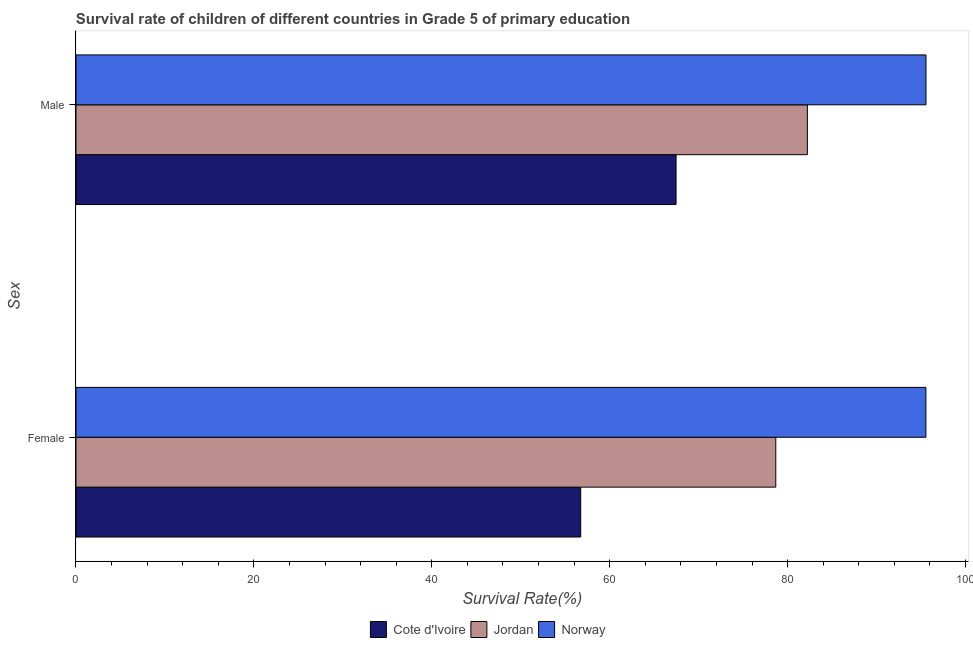How many different coloured bars are there?
Provide a short and direct response. 3. Are the number of bars per tick equal to the number of legend labels?
Provide a short and direct response. Yes. Are the number of bars on each tick of the Y-axis equal?
Your response must be concise. Yes. What is the label of the 1st group of bars from the top?
Offer a terse response. Male. What is the survival rate of male students in primary education in Jordan?
Offer a very short reply. 82.22. Across all countries, what is the maximum survival rate of male students in primary education?
Offer a terse response. 95.55. Across all countries, what is the minimum survival rate of male students in primary education?
Your answer should be compact. 67.46. In which country was the survival rate of male students in primary education minimum?
Your answer should be very brief. Cote d'Ivoire. What is the total survival rate of male students in primary education in the graph?
Offer a very short reply. 245.23. What is the difference between the survival rate of female students in primary education in Norway and that in Cote d'Ivoire?
Offer a very short reply. 38.8. What is the difference between the survival rate of female students in primary education in Norway and the survival rate of male students in primary education in Cote d'Ivoire?
Make the answer very short. 28.09. What is the average survival rate of female students in primary education per country?
Your response must be concise. 76.98. What is the difference between the survival rate of female students in primary education and survival rate of male students in primary education in Norway?
Offer a terse response. -0.01. In how many countries, is the survival rate of male students in primary education greater than 80 %?
Make the answer very short. 2. What is the ratio of the survival rate of male students in primary education in Cote d'Ivoire to that in Norway?
Ensure brevity in your answer.  0.71. Is the survival rate of male students in primary education in Cote d'Ivoire less than that in Norway?
Provide a short and direct response. Yes. In how many countries, is the survival rate of female students in primary education greater than the average survival rate of female students in primary education taken over all countries?
Provide a succinct answer. 2. What does the 2nd bar from the top in Male represents?
Offer a terse response. Jordan. What does the 3rd bar from the bottom in Female represents?
Provide a succinct answer. Norway. Are all the bars in the graph horizontal?
Give a very brief answer. Yes. Does the graph contain any zero values?
Your response must be concise. No. Does the graph contain grids?
Make the answer very short. No. How are the legend labels stacked?
Offer a very short reply. Horizontal. What is the title of the graph?
Your answer should be very brief. Survival rate of children of different countries in Grade 5 of primary education. Does "Finland" appear as one of the legend labels in the graph?
Offer a terse response. No. What is the label or title of the X-axis?
Provide a short and direct response. Survival Rate(%). What is the label or title of the Y-axis?
Make the answer very short. Sex. What is the Survival Rate(%) of Cote d'Ivoire in Female?
Make the answer very short. 56.74. What is the Survival Rate(%) of Jordan in Female?
Your answer should be compact. 78.67. What is the Survival Rate(%) in Norway in Female?
Your answer should be very brief. 95.54. What is the Survival Rate(%) in Cote d'Ivoire in Male?
Your response must be concise. 67.46. What is the Survival Rate(%) of Jordan in Male?
Make the answer very short. 82.22. What is the Survival Rate(%) of Norway in Male?
Provide a succinct answer. 95.55. Across all Sex, what is the maximum Survival Rate(%) in Cote d'Ivoire?
Ensure brevity in your answer.  67.46. Across all Sex, what is the maximum Survival Rate(%) of Jordan?
Your answer should be compact. 82.22. Across all Sex, what is the maximum Survival Rate(%) of Norway?
Keep it short and to the point. 95.55. Across all Sex, what is the minimum Survival Rate(%) of Cote d'Ivoire?
Your response must be concise. 56.74. Across all Sex, what is the minimum Survival Rate(%) of Jordan?
Ensure brevity in your answer.  78.67. Across all Sex, what is the minimum Survival Rate(%) in Norway?
Give a very brief answer. 95.54. What is the total Survival Rate(%) in Cote d'Ivoire in the graph?
Your answer should be compact. 124.19. What is the total Survival Rate(%) of Jordan in the graph?
Offer a very short reply. 160.88. What is the total Survival Rate(%) in Norway in the graph?
Your answer should be very brief. 191.09. What is the difference between the Survival Rate(%) of Cote d'Ivoire in Female and that in Male?
Give a very brief answer. -10.72. What is the difference between the Survival Rate(%) of Jordan in Female and that in Male?
Give a very brief answer. -3.55. What is the difference between the Survival Rate(%) in Norway in Female and that in Male?
Give a very brief answer. -0.01. What is the difference between the Survival Rate(%) in Cote d'Ivoire in Female and the Survival Rate(%) in Jordan in Male?
Give a very brief answer. -25.48. What is the difference between the Survival Rate(%) in Cote d'Ivoire in Female and the Survival Rate(%) in Norway in Male?
Offer a terse response. -38.81. What is the difference between the Survival Rate(%) of Jordan in Female and the Survival Rate(%) of Norway in Male?
Provide a short and direct response. -16.89. What is the average Survival Rate(%) in Cote d'Ivoire per Sex?
Ensure brevity in your answer.  62.1. What is the average Survival Rate(%) in Jordan per Sex?
Your response must be concise. 80.44. What is the average Survival Rate(%) of Norway per Sex?
Your response must be concise. 95.55. What is the difference between the Survival Rate(%) of Cote d'Ivoire and Survival Rate(%) of Jordan in Female?
Provide a succinct answer. -21.93. What is the difference between the Survival Rate(%) in Cote d'Ivoire and Survival Rate(%) in Norway in Female?
Give a very brief answer. -38.8. What is the difference between the Survival Rate(%) in Jordan and Survival Rate(%) in Norway in Female?
Make the answer very short. -16.88. What is the difference between the Survival Rate(%) of Cote d'Ivoire and Survival Rate(%) of Jordan in Male?
Offer a very short reply. -14.76. What is the difference between the Survival Rate(%) in Cote d'Ivoire and Survival Rate(%) in Norway in Male?
Your answer should be very brief. -28.1. What is the difference between the Survival Rate(%) in Jordan and Survival Rate(%) in Norway in Male?
Make the answer very short. -13.33. What is the ratio of the Survival Rate(%) of Cote d'Ivoire in Female to that in Male?
Your answer should be compact. 0.84. What is the ratio of the Survival Rate(%) of Jordan in Female to that in Male?
Your response must be concise. 0.96. What is the ratio of the Survival Rate(%) of Norway in Female to that in Male?
Offer a terse response. 1. What is the difference between the highest and the second highest Survival Rate(%) in Cote d'Ivoire?
Your answer should be very brief. 10.72. What is the difference between the highest and the second highest Survival Rate(%) of Jordan?
Your answer should be very brief. 3.55. What is the difference between the highest and the second highest Survival Rate(%) of Norway?
Offer a very short reply. 0.01. What is the difference between the highest and the lowest Survival Rate(%) of Cote d'Ivoire?
Give a very brief answer. 10.72. What is the difference between the highest and the lowest Survival Rate(%) in Jordan?
Give a very brief answer. 3.55. What is the difference between the highest and the lowest Survival Rate(%) of Norway?
Provide a succinct answer. 0.01. 